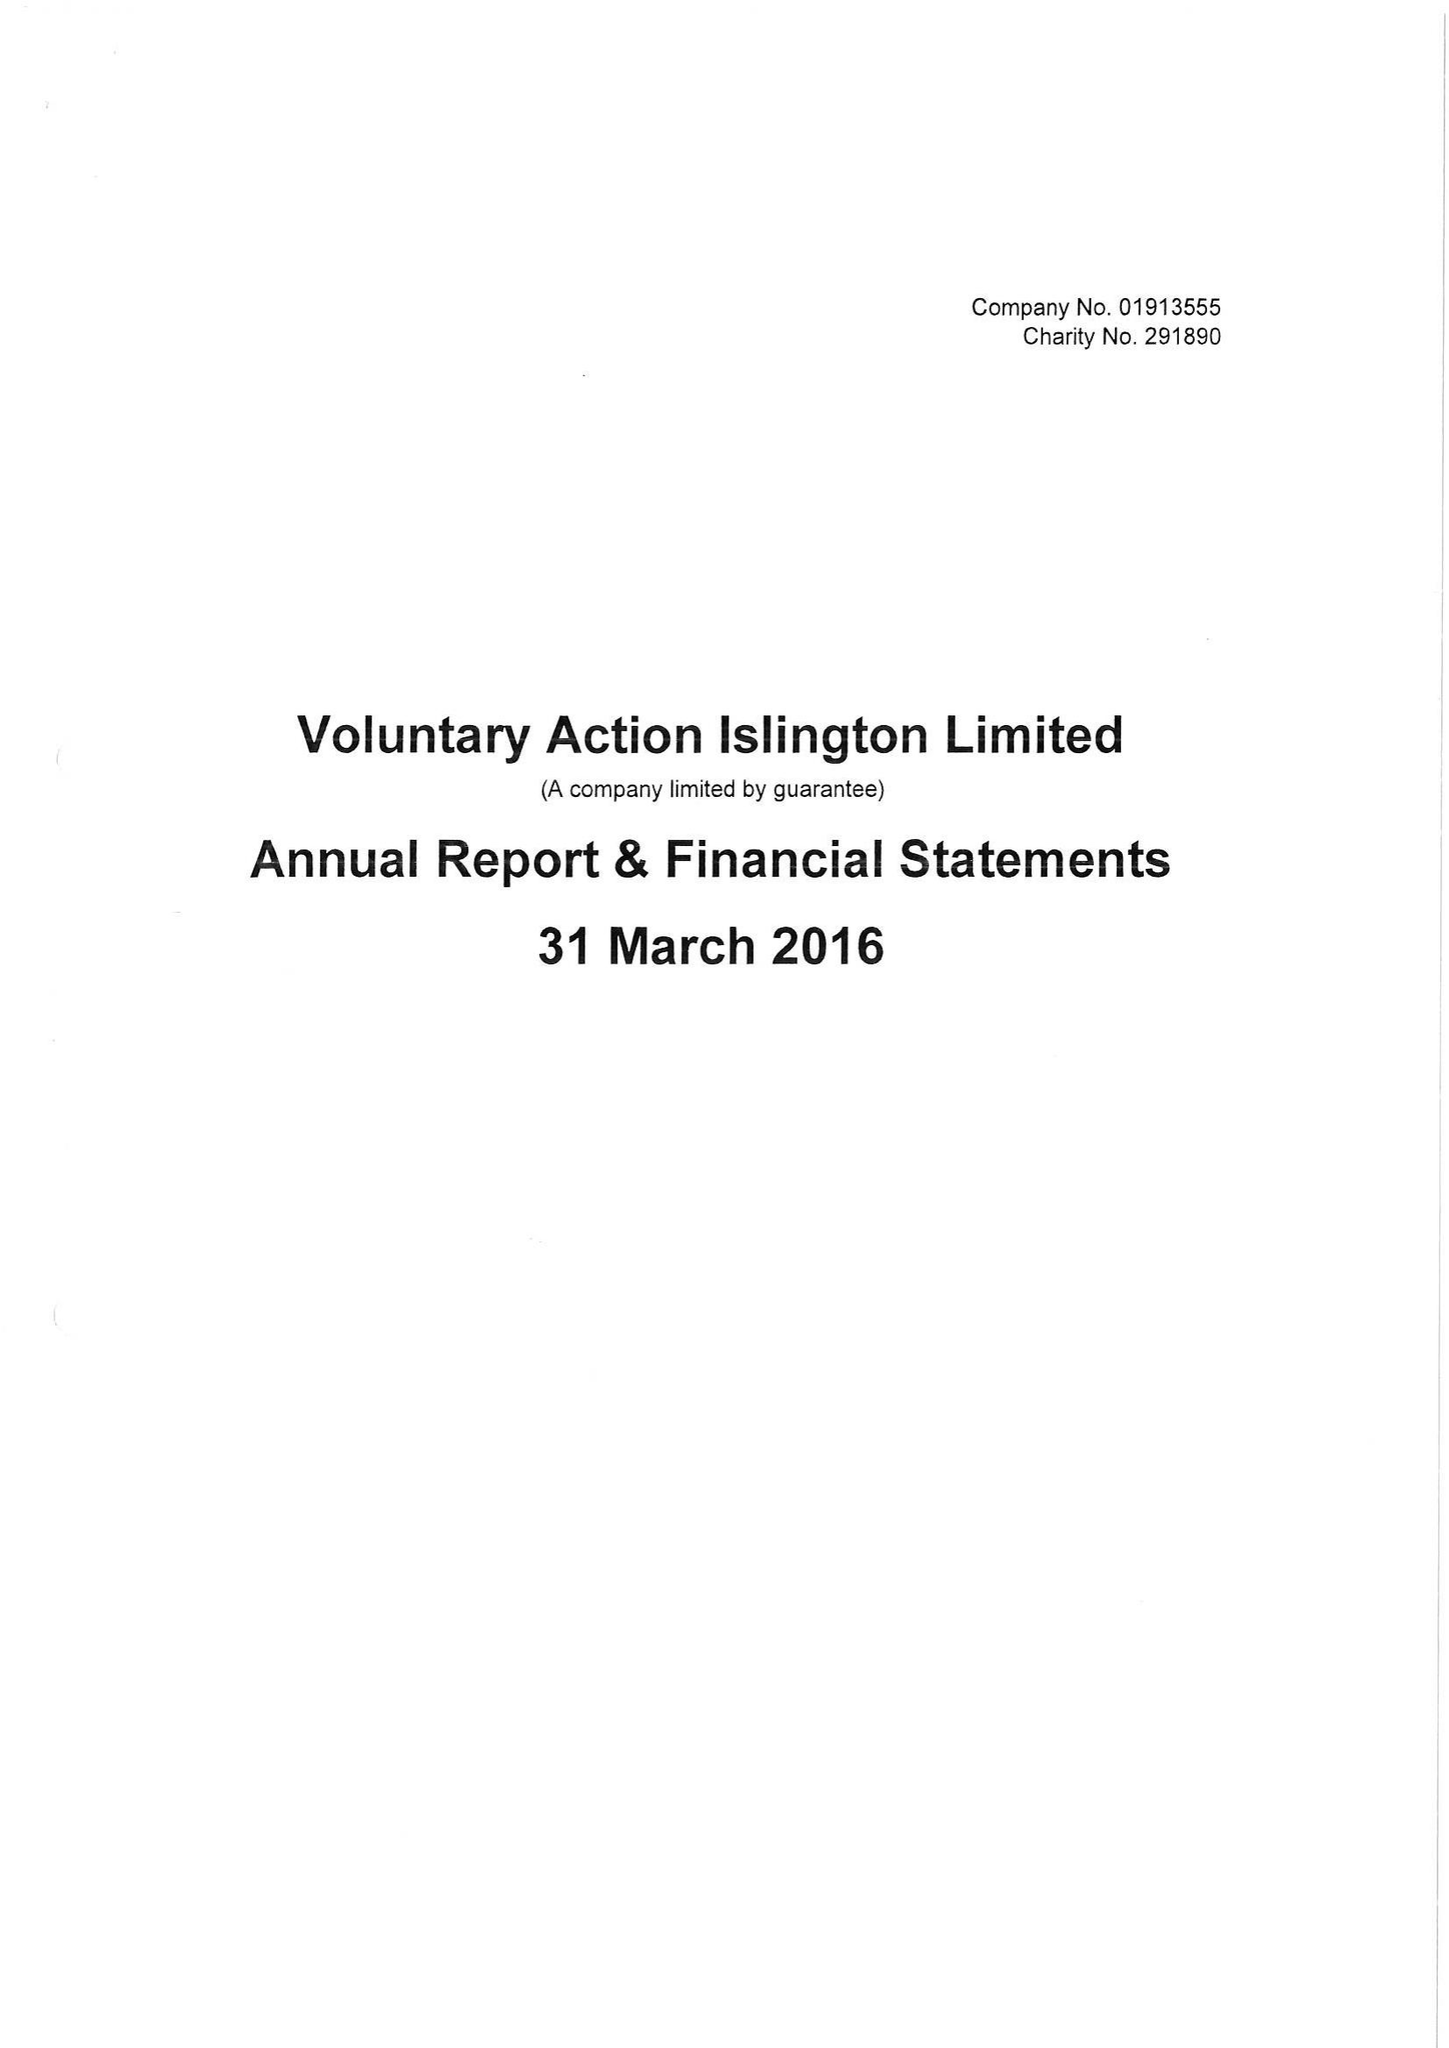What is the value for the income_annually_in_british_pounds?
Answer the question using a single word or phrase. 493627.00 